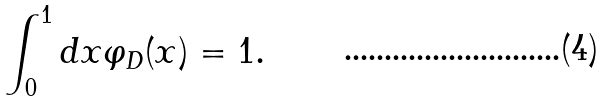Convert formula to latex. <formula><loc_0><loc_0><loc_500><loc_500>\int ^ { 1 } _ { 0 } { d x \varphi _ { D } ( x ) } = 1 .</formula> 